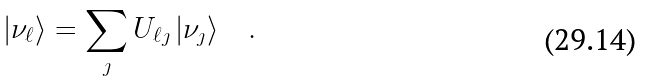<formula> <loc_0><loc_0><loc_500><loc_500>| \nu _ { \ell } \rangle = \sum _ { \jmath } U _ { \ell \jmath } \, | \nu _ { \jmath } \rangle \quad .</formula> 